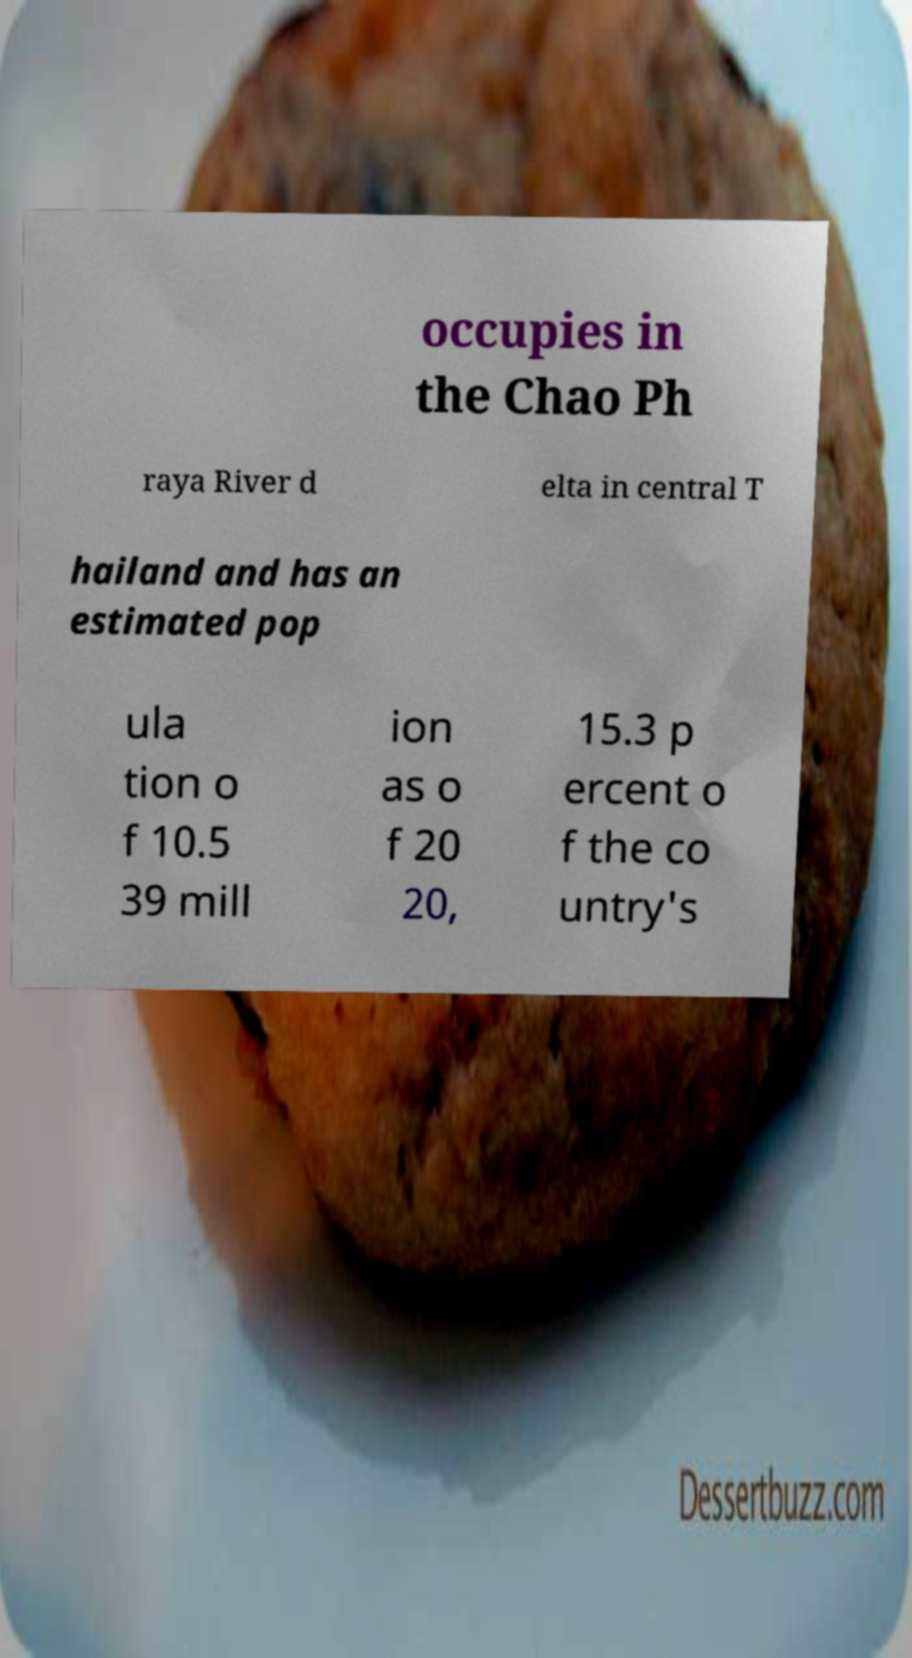Could you assist in decoding the text presented in this image and type it out clearly? occupies in the Chao Ph raya River d elta in central T hailand and has an estimated pop ula tion o f 10.5 39 mill ion as o f 20 20, 15.3 p ercent o f the co untry's 